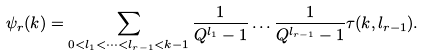Convert formula to latex. <formula><loc_0><loc_0><loc_500><loc_500>\psi _ { r } ( k ) = \sum _ { 0 < l _ { 1 } < \dots < l _ { r - 1 } < k - 1 } \frac { 1 } { Q ^ { l _ { 1 } } - 1 } \dots \frac { 1 } { Q ^ { l _ { r - 1 } } - 1 } \tau ( k , l _ { r - 1 } ) .</formula> 